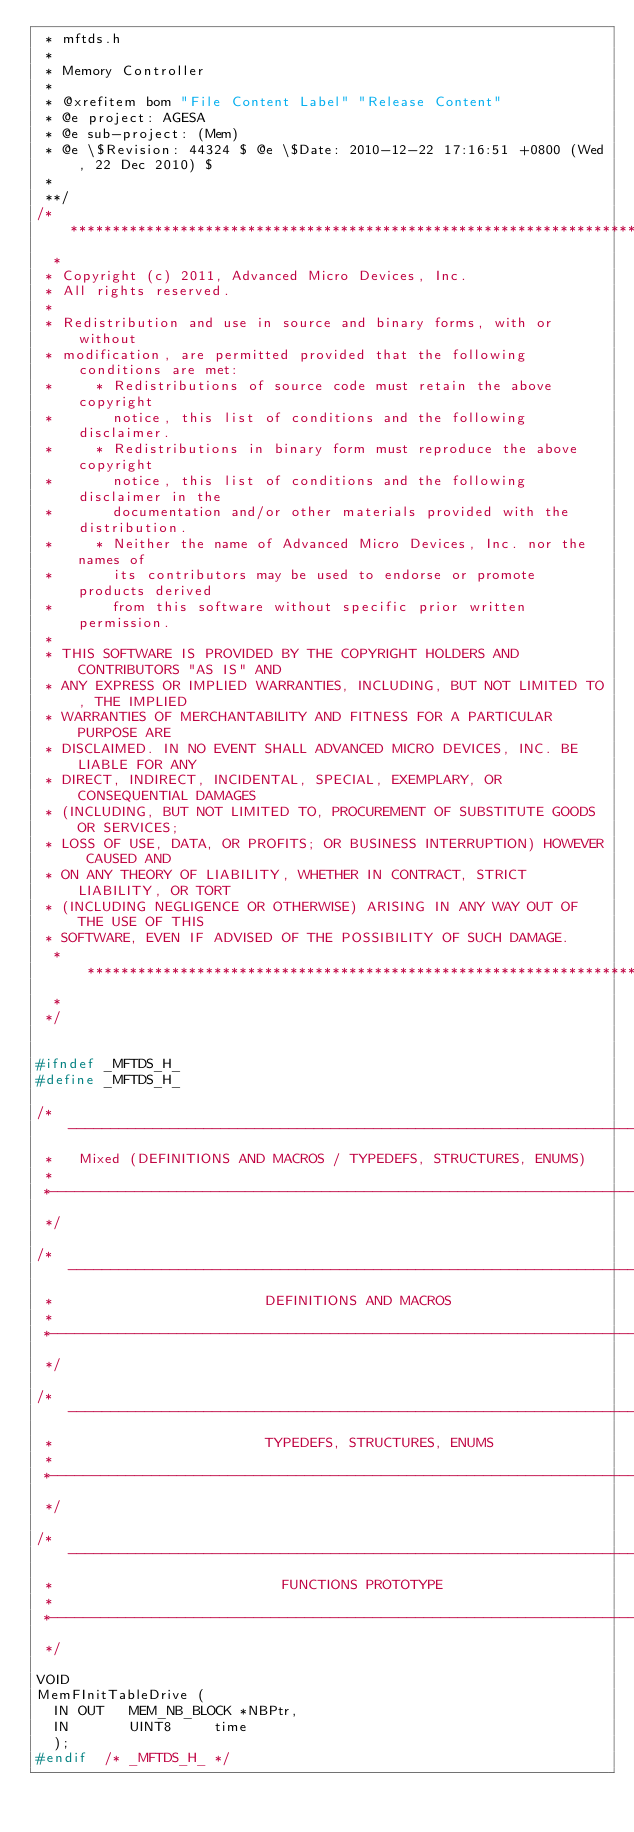<code> <loc_0><loc_0><loc_500><loc_500><_C_> * mftds.h
 *
 * Memory Controller
 *
 * @xrefitem bom "File Content Label" "Release Content"
 * @e project: AGESA
 * @e sub-project: (Mem)
 * @e \$Revision: 44324 $ @e \$Date: 2010-12-22 17:16:51 +0800 (Wed, 22 Dec 2010) $
 *
 **/
/*****************************************************************************
  *
 * Copyright (c) 2011, Advanced Micro Devices, Inc.
 * All rights reserved.
 *
 * Redistribution and use in source and binary forms, with or without
 * modification, are permitted provided that the following conditions are met:
 *     * Redistributions of source code must retain the above copyright
 *       notice, this list of conditions and the following disclaimer.
 *     * Redistributions in binary form must reproduce the above copyright
 *       notice, this list of conditions and the following disclaimer in the
 *       documentation and/or other materials provided with the distribution.
 *     * Neither the name of Advanced Micro Devices, Inc. nor the names of
 *       its contributors may be used to endorse or promote products derived
 *       from this software without specific prior written permission.
 *
 * THIS SOFTWARE IS PROVIDED BY THE COPYRIGHT HOLDERS AND CONTRIBUTORS "AS IS" AND
 * ANY EXPRESS OR IMPLIED WARRANTIES, INCLUDING, BUT NOT LIMITED TO, THE IMPLIED
 * WARRANTIES OF MERCHANTABILITY AND FITNESS FOR A PARTICULAR PURPOSE ARE
 * DISCLAIMED. IN NO EVENT SHALL ADVANCED MICRO DEVICES, INC. BE LIABLE FOR ANY
 * DIRECT, INDIRECT, INCIDENTAL, SPECIAL, EXEMPLARY, OR CONSEQUENTIAL DAMAGES
 * (INCLUDING, BUT NOT LIMITED TO, PROCUREMENT OF SUBSTITUTE GOODS OR SERVICES;
 * LOSS OF USE, DATA, OR PROFITS; OR BUSINESS INTERRUPTION) HOWEVER CAUSED AND
 * ON ANY THEORY OF LIABILITY, WHETHER IN CONTRACT, STRICT LIABILITY, OR TORT
 * (INCLUDING NEGLIGENCE OR OTHERWISE) ARISING IN ANY WAY OUT OF THE USE OF THIS
 * SOFTWARE, EVEN IF ADVISED OF THE POSSIBILITY OF SUCH DAMAGE.
  * ***************************************************************************
  *
 */


#ifndef _MFTDS_H_
#define _MFTDS_H_

/*----------------------------------------------------------------------------
 *   Mixed (DEFINITIONS AND MACROS / TYPEDEFS, STRUCTURES, ENUMS)
 *
 *----------------------------------------------------------------------------
 */

/*-----------------------------------------------------------------------------
 *                         DEFINITIONS AND MACROS
 *
 *-----------------------------------------------------------------------------
 */

/*----------------------------------------------------------------------------
 *                         TYPEDEFS, STRUCTURES, ENUMS
 *
 *----------------------------------------------------------------------------
 */

/*----------------------------------------------------------------------------
 *                           FUNCTIONS PROTOTYPE
 *
 *----------------------------------------------------------------------------
 */

VOID
MemFInitTableDrive (
  IN OUT   MEM_NB_BLOCK *NBPtr,
  IN       UINT8     time
  );
#endif  /* _MFTDS_H_ */


</code> 